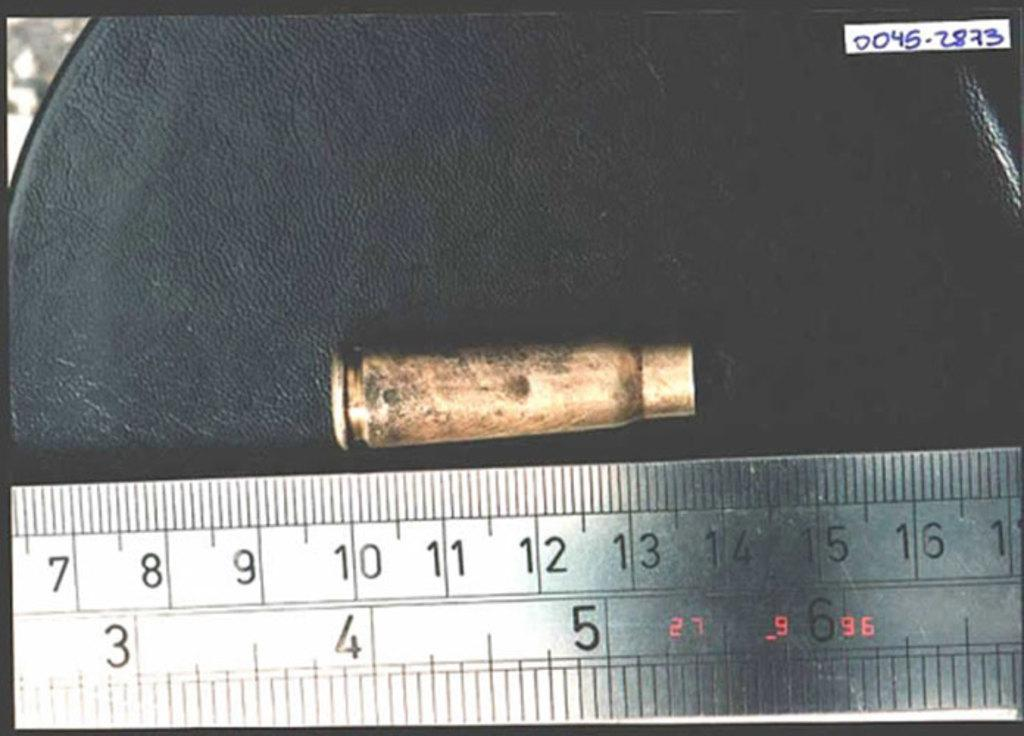<image>
Share a concise interpretation of the image provided. the number 5 is on the silver ruler 